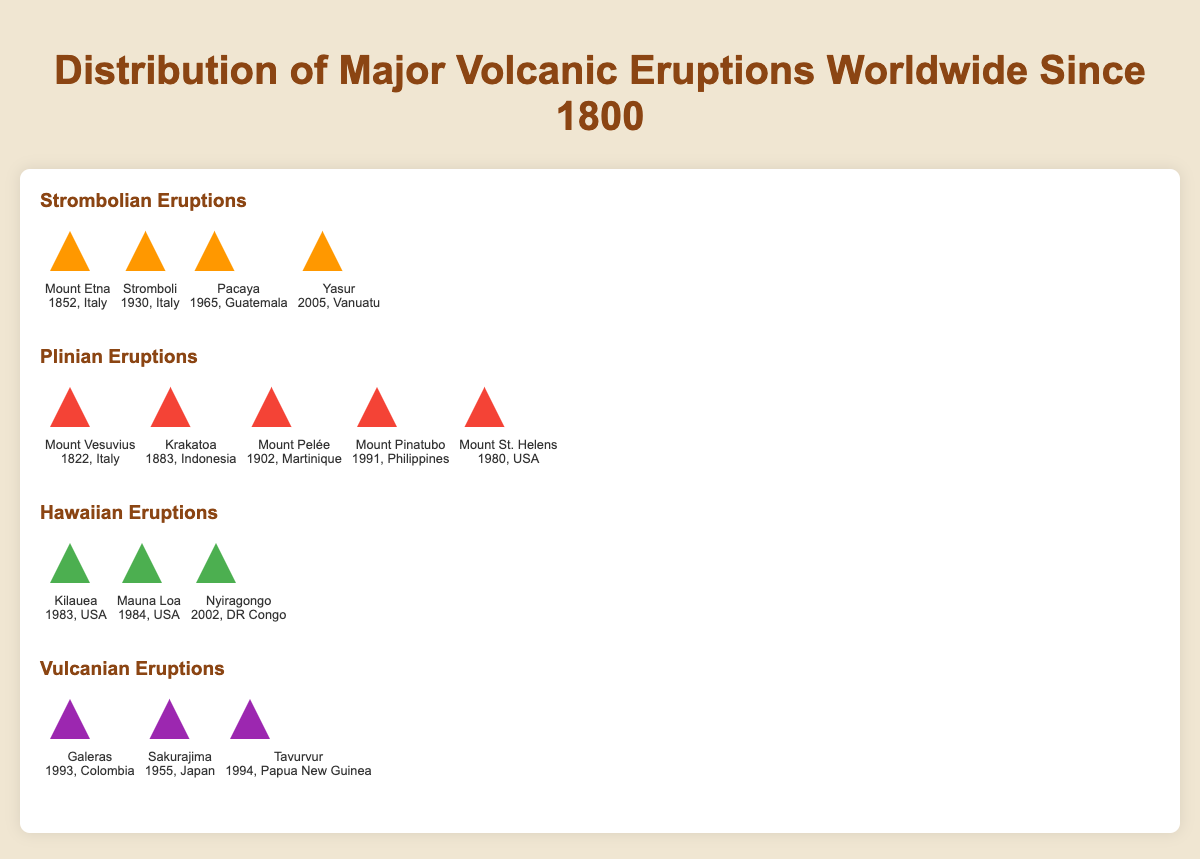What are the four types of volcanic eruptions shown in the figure? The figure categorizes volcanic eruptions into four types. The type labels are prominently displayed in bold font and different colors above each section of the isotype plot.
Answer: Strombolian, Plinian, Hawaiian, Vulcanian Which Plinian eruption occurred in 1883, and where did it happen? The Plinian section lists each eruption with its name, year, and location. The eruption that occurred in 1883 is labeled with "Krakatoa" and "Indonesia."
Answer: Krakatoa, Indonesia How many major Vulcanian eruptions are shown in the figure? The Vulcanian section displays all eruptions, each represented by an icon. Counting these icons helps determine the total number of Vulcanian eruptions.
Answer: 3 Which volcanic eruption type has the most occurrences since 1800, based on the figure? To find this, count the number of eruptions listed under each type. Compare these counts to identify the type with the highest number.
Answer: Plinian What is the most recent Strombolian eruption listed in the figure? When and where did it occur? The Strombolian eruptions are listed with their respective years. The most recent year among these entries is noted along with its associated location.
Answer: Yasur, 2005, Vanuatu How many eruptions shown in the figure occurred in the 20th century? First, identify the years from 1900 to 1999 across all eruption types. Count the number of eruptions with years within this range.
Answer: 6 Compare the number of Plinian eruptions to Strombolian eruptions; which type has more and by how much? Count the eruptions for both Plinian and Strombolian types. Calculate the difference between these counts to determine which has more and by how much.
Answer: Plinian, 1 more Which eruption happened in 1993, and what type was it? Locate the entry with the year 1993 across all types of eruptions. Identify the associated name and type based on this year.
Answer: Galeras, Vulcanian Which volcanic eruption is the oldest in the figure, and what type of eruption was it? Compare the years across all types of eruptions to determine the earliest year. Identify the eruption name and type corresponding to this year.
Answer: Mount Vesuvius, Plinian, 1822 